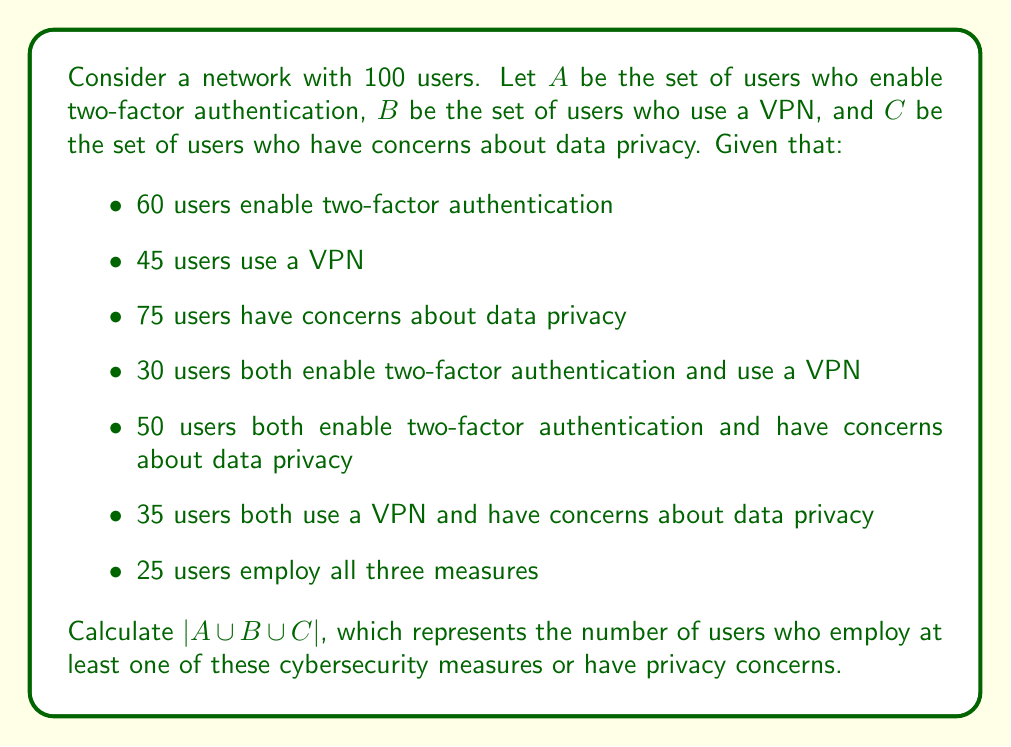Solve this math problem. To solve this problem, we'll use the Inclusion-Exclusion Principle for three sets:

$$|A \cup B \cup C| = |A| + |B| + |C| - |A \cap B| - |A \cap C| - |B \cap C| + |A \cap B \cap C|$$

We're given:
$|A| = 60$
$|B| = 45$
$|C| = 75$
$|A \cap B| = 30$
$|A \cap C| = 50$
$|B \cap C| = 35$
$|A \cap B \cap C| = 25$

Substituting these values into the formula:

$$|A \cup B \cup C| = 60 + 45 + 75 - 30 - 50 - 35 + 25$$

$$|A \cup B \cup C| = 180 - 115 + 25$$

$$|A \cup B \cup C| = 90$$

This result represents the number of users who either enable two-factor authentication, use a VPN, have privacy concerns, or any combination of these.
Answer: $|A \cup B \cup C| = 90$ 